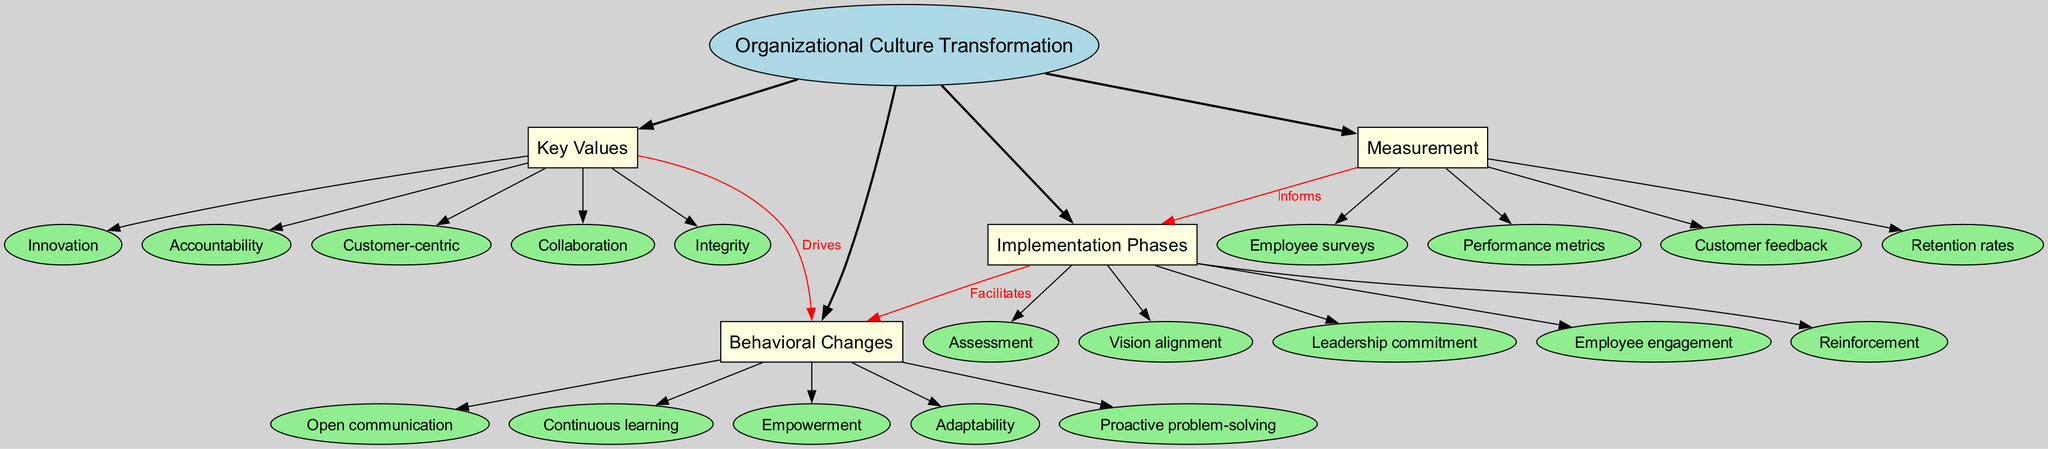What is the central concept of the diagram? The central concept is explicitly mentioned at the top of the diagram as "Organizational Culture Transformation."
Answer: Organizational Culture Transformation How many main branches are present in the diagram? The diagram displays four main branches stemming from the central concept: "Key Values," "Behavioral Changes," "Implementation Phases," and "Measurement."
Answer: 4 What value drives open communication? The pathway between "Key Values" and "Behavioral Changes" indicates that values such as "Collaboration" would drive open communication.
Answer: Collaboration Which phase facilitates behavioral changes related to employee engagement? "Implementation Phases" clearly shows that employee engagement is directly linked to the behavioral change process, highlighting that engagement facilitates these changes.
Answer: Implementation Phases What does the measurement element inform? The diagram establishes a connection indicating that the measurement informs the implementation phases. This implies that the processes of assessment, vision alignment, and others rely on the data gathered from measurement.
Answer: Implementation Phases How does accountability relate to behavioral changes? By analyzing the connections, it can be inferred that accountability (a key value) drives behavioral changes such as empowerment and adaptability, indicating its significance in transforming culture.
Answer: Drives Which two branches are directly connected by a label? The diagram illustrates connections with labels, specifically linking "Key Values" to "Behavioral Changes" and "Measurement" to "Implementation Phases." Each connection is labeled, indicating relationships clearly.
Answer: Key Values and Measurement What type of feedback is included in the measurement phase? The measurement phase specifies various feedback types, including customer feedback, which plays a vital role in assessing organizational culture transformation success.
Answer: Customer feedback 